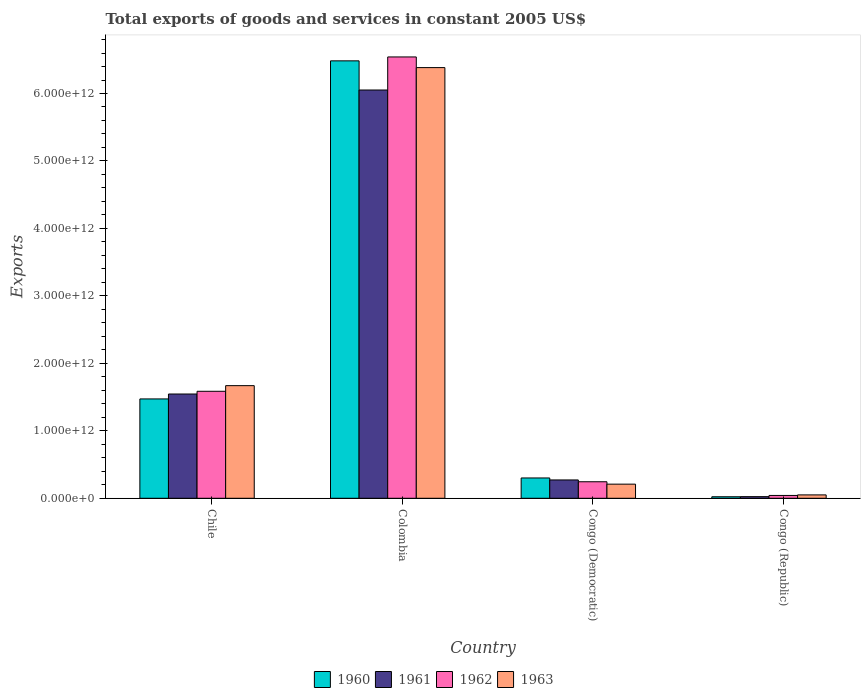Are the number of bars per tick equal to the number of legend labels?
Ensure brevity in your answer.  Yes. Are the number of bars on each tick of the X-axis equal?
Ensure brevity in your answer.  Yes. How many bars are there on the 2nd tick from the left?
Your answer should be compact. 4. In how many cases, is the number of bars for a given country not equal to the number of legend labels?
Make the answer very short. 0. What is the total exports of goods and services in 1960 in Chile?
Ensure brevity in your answer.  1.47e+12. Across all countries, what is the maximum total exports of goods and services in 1961?
Provide a succinct answer. 6.05e+12. Across all countries, what is the minimum total exports of goods and services in 1961?
Provide a short and direct response. 2.42e+1. In which country was the total exports of goods and services in 1961 maximum?
Your response must be concise. Colombia. In which country was the total exports of goods and services in 1962 minimum?
Make the answer very short. Congo (Republic). What is the total total exports of goods and services in 1962 in the graph?
Make the answer very short. 8.42e+12. What is the difference between the total exports of goods and services in 1961 in Colombia and that in Congo (Democratic)?
Your answer should be compact. 5.78e+12. What is the difference between the total exports of goods and services in 1962 in Congo (Democratic) and the total exports of goods and services in 1961 in Chile?
Offer a terse response. -1.30e+12. What is the average total exports of goods and services in 1963 per country?
Provide a short and direct response. 2.08e+12. What is the difference between the total exports of goods and services of/in 1960 and total exports of goods and services of/in 1962 in Chile?
Ensure brevity in your answer.  -1.13e+11. In how many countries, is the total exports of goods and services in 1961 greater than 4600000000000 US$?
Your answer should be compact. 1. What is the ratio of the total exports of goods and services in 1962 in Colombia to that in Congo (Democratic)?
Offer a very short reply. 26.7. Is the total exports of goods and services in 1960 in Chile less than that in Colombia?
Your response must be concise. Yes. Is the difference between the total exports of goods and services in 1960 in Chile and Colombia greater than the difference between the total exports of goods and services in 1962 in Chile and Colombia?
Ensure brevity in your answer.  No. What is the difference between the highest and the second highest total exports of goods and services in 1962?
Your response must be concise. -6.30e+12. What is the difference between the highest and the lowest total exports of goods and services in 1961?
Make the answer very short. 6.03e+12. Is the sum of the total exports of goods and services in 1963 in Colombia and Congo (Republic) greater than the maximum total exports of goods and services in 1960 across all countries?
Provide a succinct answer. No. What does the 4th bar from the left in Congo (Republic) represents?
Make the answer very short. 1963. Is it the case that in every country, the sum of the total exports of goods and services in 1962 and total exports of goods and services in 1960 is greater than the total exports of goods and services in 1963?
Provide a succinct answer. Yes. How many countries are there in the graph?
Offer a very short reply. 4. What is the difference between two consecutive major ticks on the Y-axis?
Your response must be concise. 1.00e+12. How many legend labels are there?
Your answer should be very brief. 4. How are the legend labels stacked?
Your answer should be very brief. Horizontal. What is the title of the graph?
Your answer should be compact. Total exports of goods and services in constant 2005 US$. Does "2013" appear as one of the legend labels in the graph?
Provide a short and direct response. No. What is the label or title of the Y-axis?
Offer a terse response. Exports. What is the Exports in 1960 in Chile?
Ensure brevity in your answer.  1.47e+12. What is the Exports of 1961 in Chile?
Offer a very short reply. 1.55e+12. What is the Exports in 1962 in Chile?
Keep it short and to the point. 1.59e+12. What is the Exports of 1963 in Chile?
Offer a terse response. 1.67e+12. What is the Exports of 1960 in Colombia?
Keep it short and to the point. 6.48e+12. What is the Exports in 1961 in Colombia?
Ensure brevity in your answer.  6.05e+12. What is the Exports in 1962 in Colombia?
Your answer should be compact. 6.54e+12. What is the Exports in 1963 in Colombia?
Offer a terse response. 6.38e+12. What is the Exports in 1960 in Congo (Democratic)?
Provide a succinct answer. 3.01e+11. What is the Exports in 1961 in Congo (Democratic)?
Offer a very short reply. 2.72e+11. What is the Exports in 1962 in Congo (Democratic)?
Ensure brevity in your answer.  2.45e+11. What is the Exports in 1963 in Congo (Democratic)?
Ensure brevity in your answer.  2.09e+11. What is the Exports of 1960 in Congo (Republic)?
Provide a succinct answer. 2.25e+1. What is the Exports in 1961 in Congo (Republic)?
Ensure brevity in your answer.  2.42e+1. What is the Exports of 1962 in Congo (Republic)?
Provide a short and direct response. 4.20e+1. What is the Exports of 1963 in Congo (Republic)?
Make the answer very short. 5.01e+1. Across all countries, what is the maximum Exports of 1960?
Provide a short and direct response. 6.48e+12. Across all countries, what is the maximum Exports of 1961?
Ensure brevity in your answer.  6.05e+12. Across all countries, what is the maximum Exports in 1962?
Offer a terse response. 6.54e+12. Across all countries, what is the maximum Exports of 1963?
Ensure brevity in your answer.  6.38e+12. Across all countries, what is the minimum Exports of 1960?
Your answer should be compact. 2.25e+1. Across all countries, what is the minimum Exports in 1961?
Your response must be concise. 2.42e+1. Across all countries, what is the minimum Exports in 1962?
Your response must be concise. 4.20e+1. Across all countries, what is the minimum Exports of 1963?
Your answer should be compact. 5.01e+1. What is the total Exports of 1960 in the graph?
Make the answer very short. 8.28e+12. What is the total Exports in 1961 in the graph?
Offer a terse response. 7.89e+12. What is the total Exports of 1962 in the graph?
Your answer should be compact. 8.42e+12. What is the total Exports of 1963 in the graph?
Your answer should be compact. 8.31e+12. What is the difference between the Exports of 1960 in Chile and that in Colombia?
Keep it short and to the point. -5.01e+12. What is the difference between the Exports of 1961 in Chile and that in Colombia?
Offer a very short reply. -4.51e+12. What is the difference between the Exports in 1962 in Chile and that in Colombia?
Ensure brevity in your answer.  -4.96e+12. What is the difference between the Exports in 1963 in Chile and that in Colombia?
Provide a succinct answer. -4.71e+12. What is the difference between the Exports of 1960 in Chile and that in Congo (Democratic)?
Make the answer very short. 1.17e+12. What is the difference between the Exports in 1961 in Chile and that in Congo (Democratic)?
Your response must be concise. 1.27e+12. What is the difference between the Exports of 1962 in Chile and that in Congo (Democratic)?
Your response must be concise. 1.34e+12. What is the difference between the Exports in 1963 in Chile and that in Congo (Democratic)?
Make the answer very short. 1.46e+12. What is the difference between the Exports in 1960 in Chile and that in Congo (Republic)?
Your answer should be compact. 1.45e+12. What is the difference between the Exports in 1961 in Chile and that in Congo (Republic)?
Keep it short and to the point. 1.52e+12. What is the difference between the Exports of 1962 in Chile and that in Congo (Republic)?
Provide a succinct answer. 1.54e+12. What is the difference between the Exports in 1963 in Chile and that in Congo (Republic)?
Ensure brevity in your answer.  1.62e+12. What is the difference between the Exports of 1960 in Colombia and that in Congo (Democratic)?
Offer a terse response. 6.18e+12. What is the difference between the Exports in 1961 in Colombia and that in Congo (Democratic)?
Ensure brevity in your answer.  5.78e+12. What is the difference between the Exports of 1962 in Colombia and that in Congo (Democratic)?
Give a very brief answer. 6.30e+12. What is the difference between the Exports in 1963 in Colombia and that in Congo (Democratic)?
Offer a terse response. 6.17e+12. What is the difference between the Exports of 1960 in Colombia and that in Congo (Republic)?
Keep it short and to the point. 6.46e+12. What is the difference between the Exports of 1961 in Colombia and that in Congo (Republic)?
Your answer should be compact. 6.03e+12. What is the difference between the Exports in 1962 in Colombia and that in Congo (Republic)?
Your answer should be very brief. 6.50e+12. What is the difference between the Exports of 1963 in Colombia and that in Congo (Republic)?
Provide a succinct answer. 6.33e+12. What is the difference between the Exports in 1960 in Congo (Democratic) and that in Congo (Republic)?
Offer a terse response. 2.79e+11. What is the difference between the Exports in 1961 in Congo (Democratic) and that in Congo (Republic)?
Provide a short and direct response. 2.48e+11. What is the difference between the Exports of 1962 in Congo (Democratic) and that in Congo (Republic)?
Ensure brevity in your answer.  2.03e+11. What is the difference between the Exports of 1963 in Congo (Democratic) and that in Congo (Republic)?
Offer a very short reply. 1.59e+11. What is the difference between the Exports in 1960 in Chile and the Exports in 1961 in Colombia?
Offer a terse response. -4.58e+12. What is the difference between the Exports in 1960 in Chile and the Exports in 1962 in Colombia?
Provide a short and direct response. -5.07e+12. What is the difference between the Exports of 1960 in Chile and the Exports of 1963 in Colombia?
Keep it short and to the point. -4.91e+12. What is the difference between the Exports in 1961 in Chile and the Exports in 1962 in Colombia?
Give a very brief answer. -5.00e+12. What is the difference between the Exports of 1961 in Chile and the Exports of 1963 in Colombia?
Give a very brief answer. -4.84e+12. What is the difference between the Exports of 1962 in Chile and the Exports of 1963 in Colombia?
Offer a terse response. -4.80e+12. What is the difference between the Exports of 1960 in Chile and the Exports of 1961 in Congo (Democratic)?
Offer a terse response. 1.20e+12. What is the difference between the Exports in 1960 in Chile and the Exports in 1962 in Congo (Democratic)?
Offer a terse response. 1.23e+12. What is the difference between the Exports in 1960 in Chile and the Exports in 1963 in Congo (Democratic)?
Keep it short and to the point. 1.26e+12. What is the difference between the Exports of 1961 in Chile and the Exports of 1962 in Congo (Democratic)?
Make the answer very short. 1.30e+12. What is the difference between the Exports of 1961 in Chile and the Exports of 1963 in Congo (Democratic)?
Provide a short and direct response. 1.34e+12. What is the difference between the Exports in 1962 in Chile and the Exports in 1963 in Congo (Democratic)?
Provide a short and direct response. 1.38e+12. What is the difference between the Exports in 1960 in Chile and the Exports in 1961 in Congo (Republic)?
Provide a short and direct response. 1.45e+12. What is the difference between the Exports of 1960 in Chile and the Exports of 1962 in Congo (Republic)?
Your answer should be compact. 1.43e+12. What is the difference between the Exports in 1960 in Chile and the Exports in 1963 in Congo (Republic)?
Your answer should be compact. 1.42e+12. What is the difference between the Exports in 1961 in Chile and the Exports in 1962 in Congo (Republic)?
Provide a succinct answer. 1.50e+12. What is the difference between the Exports of 1961 in Chile and the Exports of 1963 in Congo (Republic)?
Ensure brevity in your answer.  1.50e+12. What is the difference between the Exports in 1962 in Chile and the Exports in 1963 in Congo (Republic)?
Provide a succinct answer. 1.54e+12. What is the difference between the Exports of 1960 in Colombia and the Exports of 1961 in Congo (Democratic)?
Provide a short and direct response. 6.21e+12. What is the difference between the Exports of 1960 in Colombia and the Exports of 1962 in Congo (Democratic)?
Provide a succinct answer. 6.24e+12. What is the difference between the Exports in 1960 in Colombia and the Exports in 1963 in Congo (Democratic)?
Provide a short and direct response. 6.27e+12. What is the difference between the Exports of 1961 in Colombia and the Exports of 1962 in Congo (Democratic)?
Your answer should be compact. 5.81e+12. What is the difference between the Exports in 1961 in Colombia and the Exports in 1963 in Congo (Democratic)?
Offer a terse response. 5.84e+12. What is the difference between the Exports of 1962 in Colombia and the Exports of 1963 in Congo (Democratic)?
Your answer should be compact. 6.33e+12. What is the difference between the Exports of 1960 in Colombia and the Exports of 1961 in Congo (Republic)?
Provide a short and direct response. 6.46e+12. What is the difference between the Exports of 1960 in Colombia and the Exports of 1962 in Congo (Republic)?
Your answer should be compact. 6.44e+12. What is the difference between the Exports of 1960 in Colombia and the Exports of 1963 in Congo (Republic)?
Your answer should be compact. 6.43e+12. What is the difference between the Exports of 1961 in Colombia and the Exports of 1962 in Congo (Republic)?
Offer a very short reply. 6.01e+12. What is the difference between the Exports of 1961 in Colombia and the Exports of 1963 in Congo (Republic)?
Make the answer very short. 6.00e+12. What is the difference between the Exports of 1962 in Colombia and the Exports of 1963 in Congo (Republic)?
Keep it short and to the point. 6.49e+12. What is the difference between the Exports in 1960 in Congo (Democratic) and the Exports in 1961 in Congo (Republic)?
Offer a terse response. 2.77e+11. What is the difference between the Exports in 1960 in Congo (Democratic) and the Exports in 1962 in Congo (Republic)?
Provide a succinct answer. 2.59e+11. What is the difference between the Exports in 1960 in Congo (Democratic) and the Exports in 1963 in Congo (Republic)?
Offer a very short reply. 2.51e+11. What is the difference between the Exports in 1961 in Congo (Democratic) and the Exports in 1962 in Congo (Republic)?
Provide a succinct answer. 2.30e+11. What is the difference between the Exports in 1961 in Congo (Democratic) and the Exports in 1963 in Congo (Republic)?
Your response must be concise. 2.22e+11. What is the difference between the Exports in 1962 in Congo (Democratic) and the Exports in 1963 in Congo (Republic)?
Ensure brevity in your answer.  1.95e+11. What is the average Exports in 1960 per country?
Your response must be concise. 2.07e+12. What is the average Exports in 1961 per country?
Offer a very short reply. 1.97e+12. What is the average Exports of 1962 per country?
Offer a very short reply. 2.10e+12. What is the average Exports in 1963 per country?
Provide a short and direct response. 2.08e+12. What is the difference between the Exports of 1960 and Exports of 1961 in Chile?
Ensure brevity in your answer.  -7.28e+1. What is the difference between the Exports in 1960 and Exports in 1962 in Chile?
Provide a succinct answer. -1.13e+11. What is the difference between the Exports in 1960 and Exports in 1963 in Chile?
Your answer should be compact. -1.97e+11. What is the difference between the Exports in 1961 and Exports in 1962 in Chile?
Offer a terse response. -4.03e+1. What is the difference between the Exports in 1961 and Exports in 1963 in Chile?
Offer a very short reply. -1.24e+11. What is the difference between the Exports of 1962 and Exports of 1963 in Chile?
Your answer should be very brief. -8.37e+1. What is the difference between the Exports of 1960 and Exports of 1961 in Colombia?
Make the answer very short. 4.32e+11. What is the difference between the Exports of 1960 and Exports of 1962 in Colombia?
Ensure brevity in your answer.  -5.79e+1. What is the difference between the Exports in 1960 and Exports in 1963 in Colombia?
Provide a short and direct response. 1.00e+11. What is the difference between the Exports of 1961 and Exports of 1962 in Colombia?
Make the answer very short. -4.90e+11. What is the difference between the Exports of 1961 and Exports of 1963 in Colombia?
Your answer should be compact. -3.32e+11. What is the difference between the Exports in 1962 and Exports in 1963 in Colombia?
Make the answer very short. 1.58e+11. What is the difference between the Exports of 1960 and Exports of 1961 in Congo (Democratic)?
Your answer should be very brief. 2.94e+1. What is the difference between the Exports of 1960 and Exports of 1962 in Congo (Democratic)?
Offer a terse response. 5.61e+1. What is the difference between the Exports in 1960 and Exports in 1963 in Congo (Democratic)?
Make the answer very short. 9.17e+1. What is the difference between the Exports in 1961 and Exports in 1962 in Congo (Democratic)?
Offer a terse response. 2.67e+1. What is the difference between the Exports of 1961 and Exports of 1963 in Congo (Democratic)?
Your answer should be compact. 6.23e+1. What is the difference between the Exports in 1962 and Exports in 1963 in Congo (Democratic)?
Ensure brevity in your answer.  3.56e+1. What is the difference between the Exports of 1960 and Exports of 1961 in Congo (Republic)?
Your answer should be compact. -1.69e+09. What is the difference between the Exports in 1960 and Exports in 1962 in Congo (Republic)?
Offer a terse response. -1.95e+1. What is the difference between the Exports of 1960 and Exports of 1963 in Congo (Republic)?
Make the answer very short. -2.76e+1. What is the difference between the Exports of 1961 and Exports of 1962 in Congo (Republic)?
Your response must be concise. -1.78e+1. What is the difference between the Exports in 1961 and Exports in 1963 in Congo (Republic)?
Provide a succinct answer. -2.59e+1. What is the difference between the Exports in 1962 and Exports in 1963 in Congo (Republic)?
Provide a short and direct response. -8.07e+09. What is the ratio of the Exports of 1960 in Chile to that in Colombia?
Keep it short and to the point. 0.23. What is the ratio of the Exports in 1961 in Chile to that in Colombia?
Your answer should be very brief. 0.26. What is the ratio of the Exports of 1962 in Chile to that in Colombia?
Make the answer very short. 0.24. What is the ratio of the Exports of 1963 in Chile to that in Colombia?
Provide a succinct answer. 0.26. What is the ratio of the Exports in 1960 in Chile to that in Congo (Democratic)?
Your answer should be compact. 4.89. What is the ratio of the Exports of 1961 in Chile to that in Congo (Democratic)?
Offer a very short reply. 5.69. What is the ratio of the Exports of 1962 in Chile to that in Congo (Democratic)?
Provide a succinct answer. 6.47. What is the ratio of the Exports in 1963 in Chile to that in Congo (Democratic)?
Your response must be concise. 7.97. What is the ratio of the Exports of 1960 in Chile to that in Congo (Republic)?
Give a very brief answer. 65.38. What is the ratio of the Exports of 1961 in Chile to that in Congo (Republic)?
Provide a short and direct response. 63.82. What is the ratio of the Exports in 1962 in Chile to that in Congo (Republic)?
Offer a very short reply. 37.72. What is the ratio of the Exports of 1963 in Chile to that in Congo (Republic)?
Your answer should be compact. 33.31. What is the ratio of the Exports in 1960 in Colombia to that in Congo (Democratic)?
Your answer should be compact. 21.53. What is the ratio of the Exports of 1961 in Colombia to that in Congo (Democratic)?
Provide a succinct answer. 22.27. What is the ratio of the Exports in 1962 in Colombia to that in Congo (Democratic)?
Give a very brief answer. 26.7. What is the ratio of the Exports of 1963 in Colombia to that in Congo (Democratic)?
Provide a short and direct response. 30.48. What is the ratio of the Exports of 1960 in Colombia to that in Congo (Republic)?
Make the answer very short. 287.84. What is the ratio of the Exports in 1961 in Colombia to that in Congo (Republic)?
Provide a short and direct response. 249.91. What is the ratio of the Exports in 1962 in Colombia to that in Congo (Republic)?
Provide a succinct answer. 155.58. What is the ratio of the Exports in 1963 in Colombia to that in Congo (Republic)?
Ensure brevity in your answer.  127.37. What is the ratio of the Exports of 1960 in Congo (Democratic) to that in Congo (Republic)?
Offer a very short reply. 13.37. What is the ratio of the Exports in 1961 in Congo (Democratic) to that in Congo (Republic)?
Make the answer very short. 11.22. What is the ratio of the Exports of 1962 in Congo (Democratic) to that in Congo (Republic)?
Your answer should be compact. 5.83. What is the ratio of the Exports in 1963 in Congo (Democratic) to that in Congo (Republic)?
Your response must be concise. 4.18. What is the difference between the highest and the second highest Exports in 1960?
Your answer should be very brief. 5.01e+12. What is the difference between the highest and the second highest Exports of 1961?
Offer a very short reply. 4.51e+12. What is the difference between the highest and the second highest Exports in 1962?
Your answer should be very brief. 4.96e+12. What is the difference between the highest and the second highest Exports of 1963?
Provide a succinct answer. 4.71e+12. What is the difference between the highest and the lowest Exports of 1960?
Provide a succinct answer. 6.46e+12. What is the difference between the highest and the lowest Exports in 1961?
Offer a very short reply. 6.03e+12. What is the difference between the highest and the lowest Exports in 1962?
Ensure brevity in your answer.  6.50e+12. What is the difference between the highest and the lowest Exports of 1963?
Ensure brevity in your answer.  6.33e+12. 